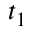<formula> <loc_0><loc_0><loc_500><loc_500>t _ { 1 }</formula> 